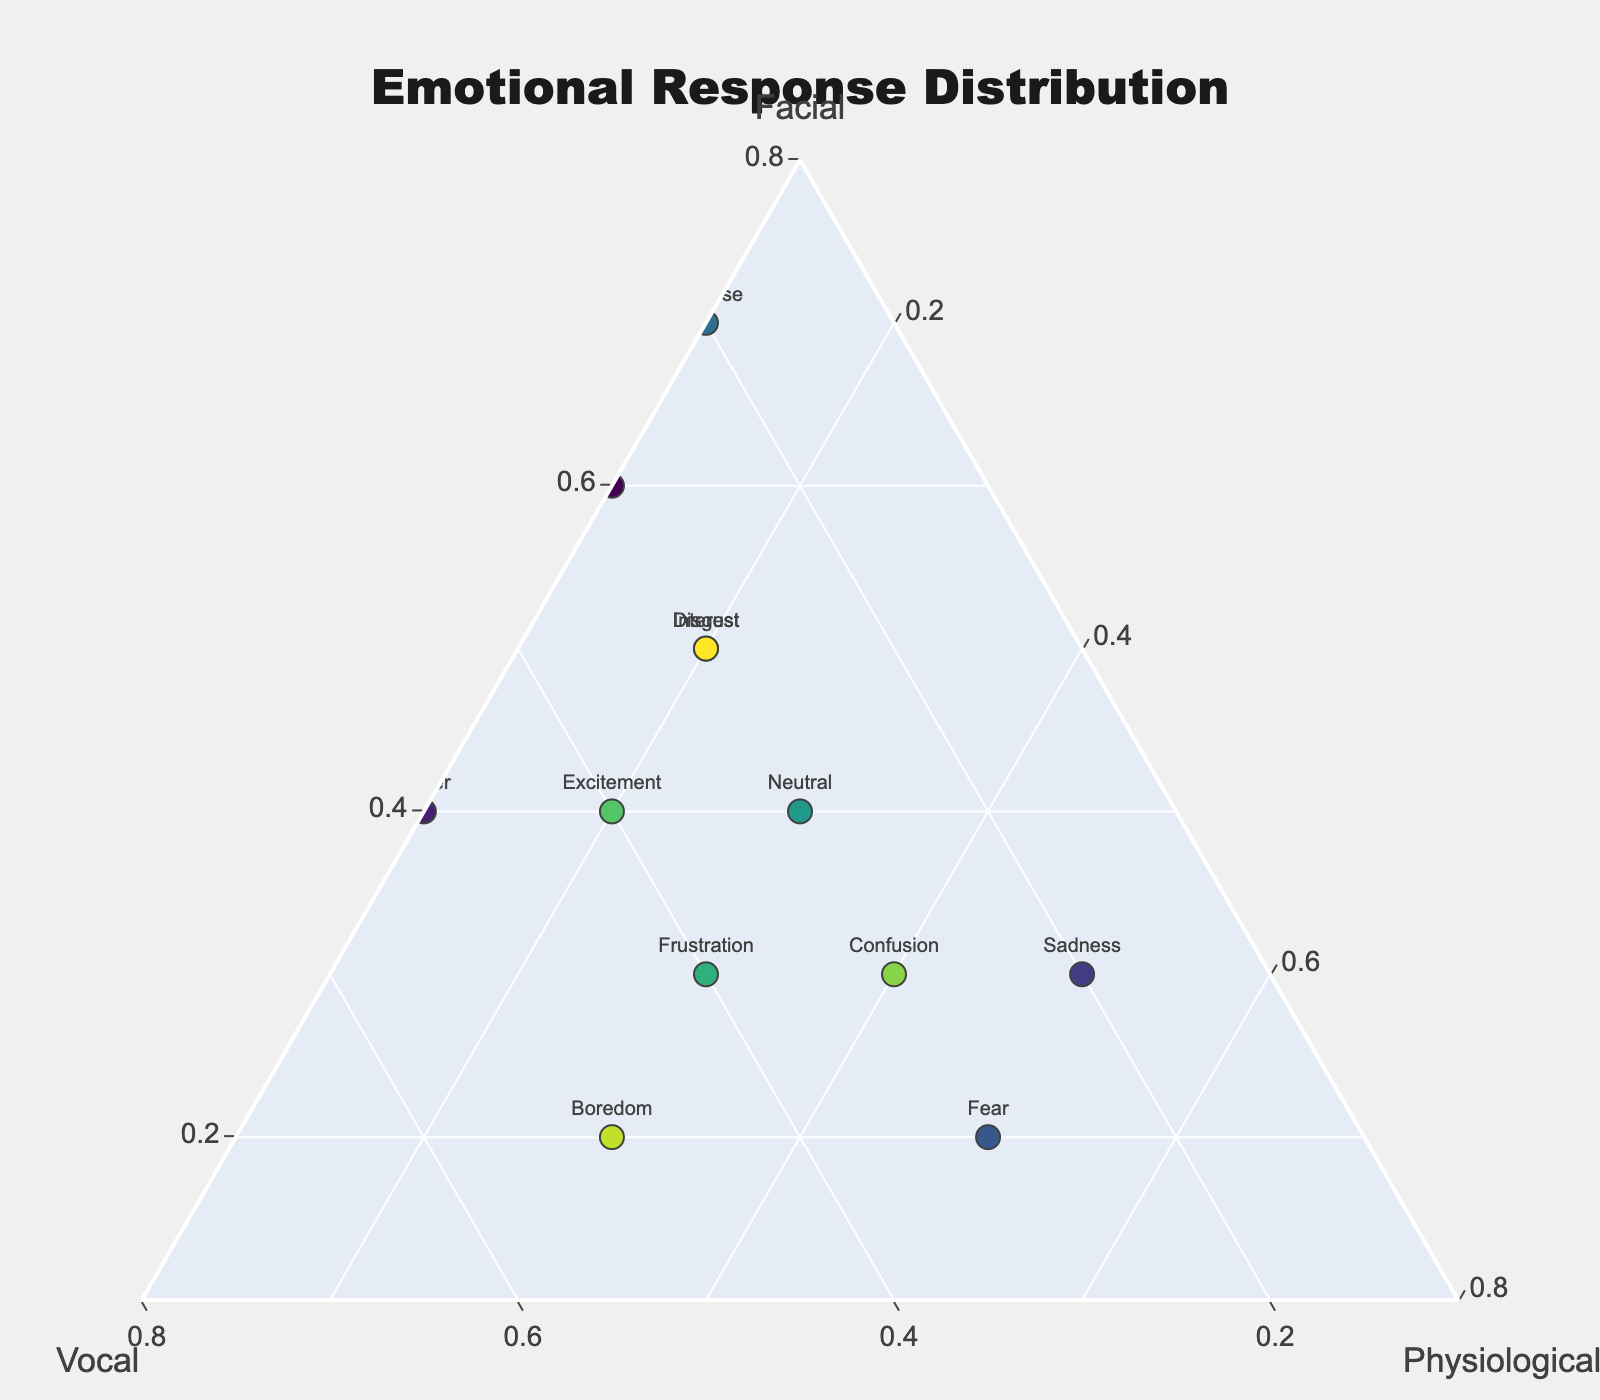What is the title of the figure? The title is located at the top of the figure. It reads "Emotional Response Distribution".
Answer: Emotional Response Distribution How many emotions are depicted in this plot? Each emotion in the dataset is represented by a marker on the Ternary Plot, and by counting them, we identify a total of 12 emotions.
Answer: 12 Which emotion has the highest facial cue contribution? By examining the markers, we see that "Surprise" is positioned farthest towards the 'Facial' axis, indicating it has the highest contribution from facial cues at 0.7.
Answer: Surprise Which emotion relies equally on vocal and physiological cues? The data point labeled "Confusion" is positioned equidistantly between the vocal and physiological axes, indicating an equal contribution of 0.3 from both cues.
Answer: Confusion What is the sum of vocal contributions for Frustration and Excitement? According to the figure, the vocal contributions for Frustration and Excitement are 0.4 each. Adding them gives 0.4 + 0.4 = 0.8.
Answer: 0.8 Which emotions have the same physiological cue contribution? By reading the plot, we find that "Joy" and "Anger" both have a physiological cue contribution of 0.1.
Answer: Joy, Anger What is the difference in facial cue contribution between Disgust and Neutral? Disgust has a facial cue of 0.5, while Neutral has 0.4. The difference is calculated by 0.5 - 0.4 = 0.1.
Answer: 0.1 Which emotion is closest to being neutral (having balanced contributions across all cues)? The emotion "Neutral" itself is closest to the center of the Ternary Plot, indicating balanced contributions of 0.4 facial, 0.3 vocal, and 0.3 physiological.
Answer: Neutral Are there any emotions with a physiological contribution greater than or equal to 0.5? By examining the 'Physiological' axis, both "Sadness" and "Fear" have physiological contributions of 0.5.
Answer: Sadness, Fear How does the facial contribution of Joy compare to that of Surprise? Joy has a facial contribution of 0.6, while Surprise has 0.7, so Surprise has a higher facial contribution than Joy.
Answer: Surprise has a higher facial contribution 